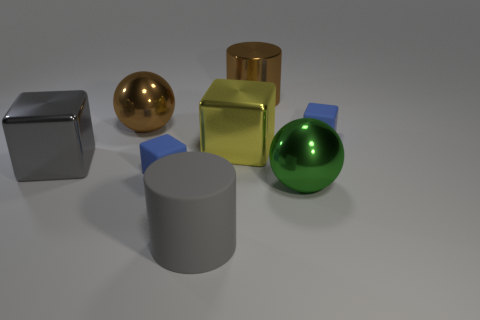Add 1 small blue objects. How many objects exist? 9 Subtract all cylinders. How many objects are left? 6 Subtract all large rubber objects. Subtract all large gray matte objects. How many objects are left? 6 Add 1 metallic blocks. How many metallic blocks are left? 3 Add 6 big yellow objects. How many big yellow objects exist? 7 Subtract 0 gray spheres. How many objects are left? 8 